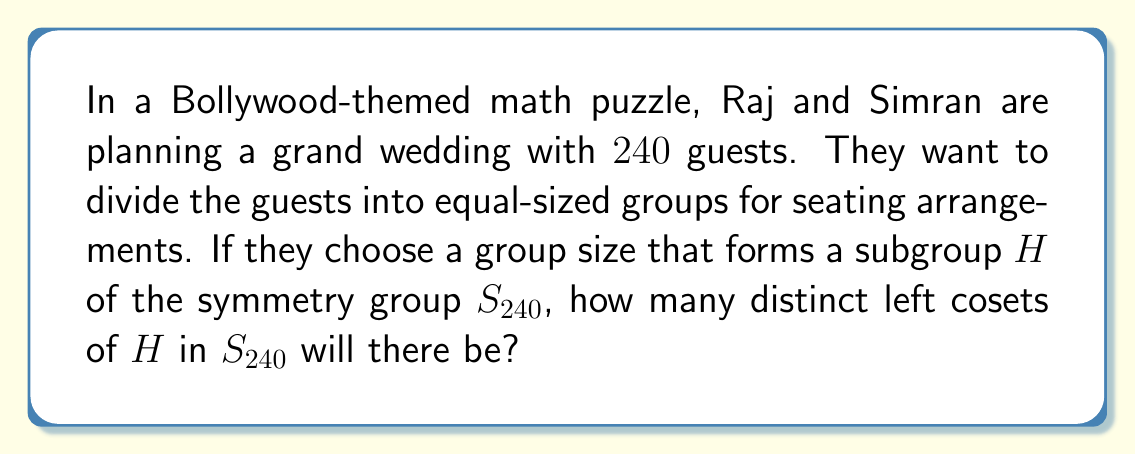Solve this math problem. Let's approach this step-by-step:

1) First, recall the Lagrange's Theorem: For a finite group $G$ and a subgroup $H$ of $G$, the order of $H$ divides the order of $G$. The number of distinct cosets of $H$ in $G$ is equal to the index of $H$ in $G$, denoted as $[G:H]$, which is calculated as:

   $[G:H] = \frac{|G|}{|H|}$

2) In this case, $G = S_{240}$, the symmetry group of 240 elements. The order of $S_{240}$ is $240!$.

3) The subgroup $H$ represents the group size for seating arrangements. Let's say this size is $n$. Then $|H| = n$.

4) For $H$ to be a subgroup of $S_{240}$, $n$ must divide $240!$.

5) The number of distinct cosets will be:

   $[S_{240}:H] = \frac{|S_{240}|}{|H|} = \frac{240!}{n}$

6) However, we need to find a specific value for $n$. In the context of the problem, a reasonable group size would be a factor of 240.

7) The factors of 240 are: 1, 2, 3, 4, 5, 6, 8, 10, 12, 15, 16, 20, 24, 30, 40, 48, 60, 80, 120, 240.

8) Any of these could be chosen as the group size. For example, if they choose groups of 24 people, then $n = 24$.

9) In this case, the number of distinct cosets would be:

   $[S_{240}:H] = \frac{240!}{24} = 10!$

This is because $240 = 24 \times 10$, so dividing 240 people into groups of 24 results in 10 groups.
Answer: The number of distinct cosets depends on the chosen group size. If groups of 24 are chosen, there will be $10! = 3,628,800$ distinct cosets of $H$ in $S_{240}$. 